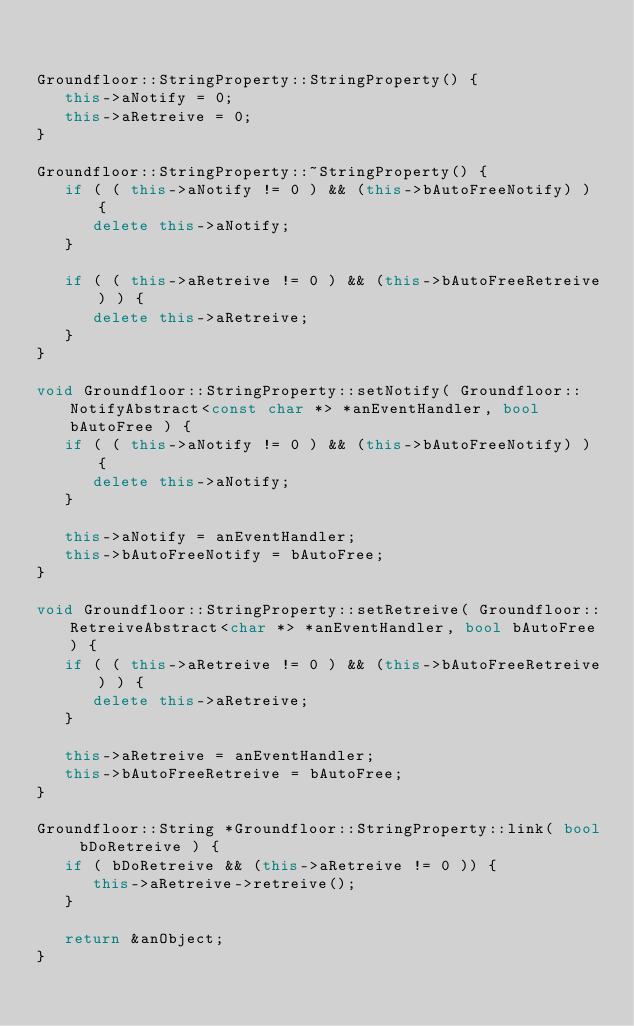<code> <loc_0><loc_0><loc_500><loc_500><_C++_>

Groundfloor::StringProperty::StringProperty() {
   this->aNotify = 0;
   this->aRetreive = 0;
}

Groundfloor::StringProperty::~StringProperty() {
   if ( ( this->aNotify != 0 ) && (this->bAutoFreeNotify) ) {
      delete this->aNotify;
   }

   if ( ( this->aRetreive != 0 ) && (this->bAutoFreeRetreive) ) {
      delete this->aRetreive;
   }
}

void Groundfloor::StringProperty::setNotify( Groundfloor::NotifyAbstract<const char *> *anEventHandler, bool bAutoFree ) {
   if ( ( this->aNotify != 0 ) && (this->bAutoFreeNotify) ) {
      delete this->aNotify;
   }

   this->aNotify = anEventHandler;
   this->bAutoFreeNotify = bAutoFree;
}

void Groundfloor::StringProperty::setRetreive( Groundfloor::RetreiveAbstract<char *> *anEventHandler, bool bAutoFree ) {
   if ( ( this->aRetreive != 0 ) && (this->bAutoFreeRetreive) ) {
      delete this->aRetreive;
   }

   this->aRetreive = anEventHandler;
   this->bAutoFreeRetreive = bAutoFree;
}

Groundfloor::String *Groundfloor::StringProperty::link( bool bDoRetreive ) {
   if ( bDoRetreive && (this->aRetreive != 0 )) {
      this->aRetreive->retreive();
   }

   return &anObject;
}
</code> 